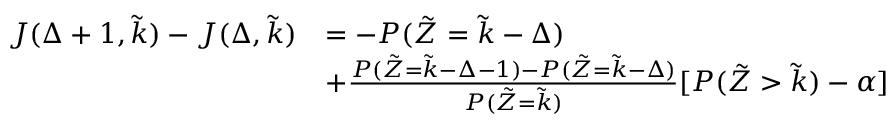<formula> <loc_0><loc_0><loc_500><loc_500>\begin{array} { r l } { J ( \Delta + 1 , \tilde { k } ) - J ( \Delta , \tilde { k } ) } & { = - P ( \tilde { Z } = \tilde { k } - \Delta ) } \\ & { + \frac { P ( \tilde { Z } = \tilde { k } - \Delta - 1 ) - P ( \tilde { Z } = \tilde { k } - \Delta ) } { P ( \tilde { Z } = \tilde { k } ) } [ P ( \tilde { Z } > \tilde { k } ) - \alpha ] } \end{array}</formula> 